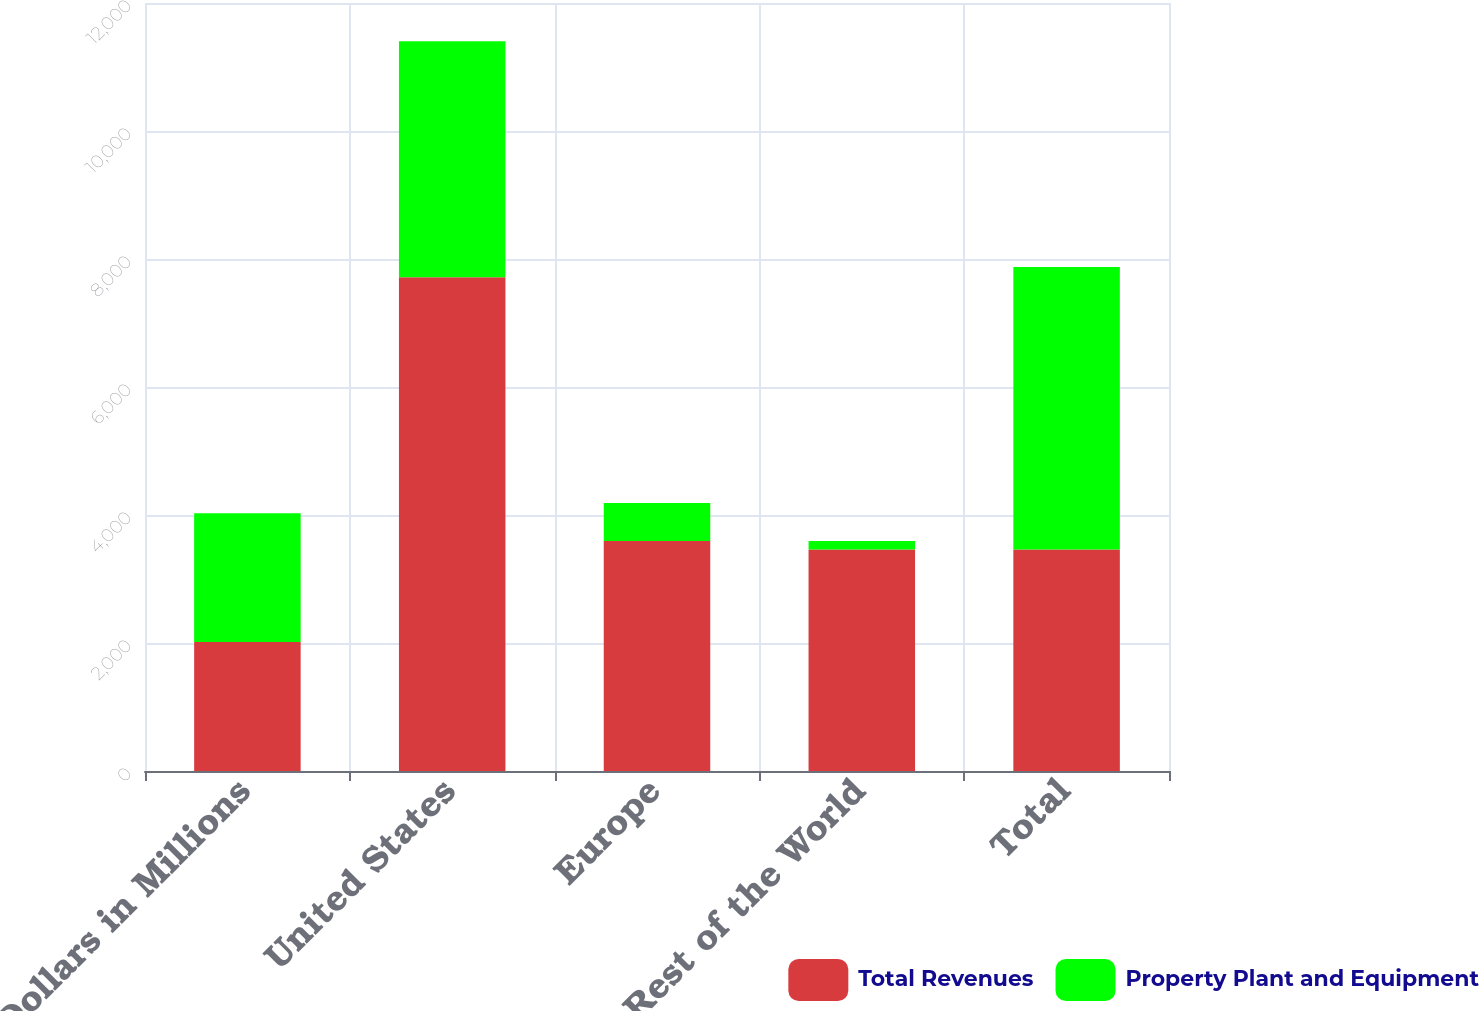Convert chart. <chart><loc_0><loc_0><loc_500><loc_500><stacked_bar_chart><ecel><fcel>Dollars in Millions<fcel>United States<fcel>Europe<fcel>Rest of the World<fcel>Total<nl><fcel>Total Revenues<fcel>2014<fcel>7716<fcel>3592<fcel>3459<fcel>3459<nl><fcel>Property Plant and Equipment<fcel>2014<fcel>3686<fcel>597<fcel>134<fcel>4417<nl></chart> 